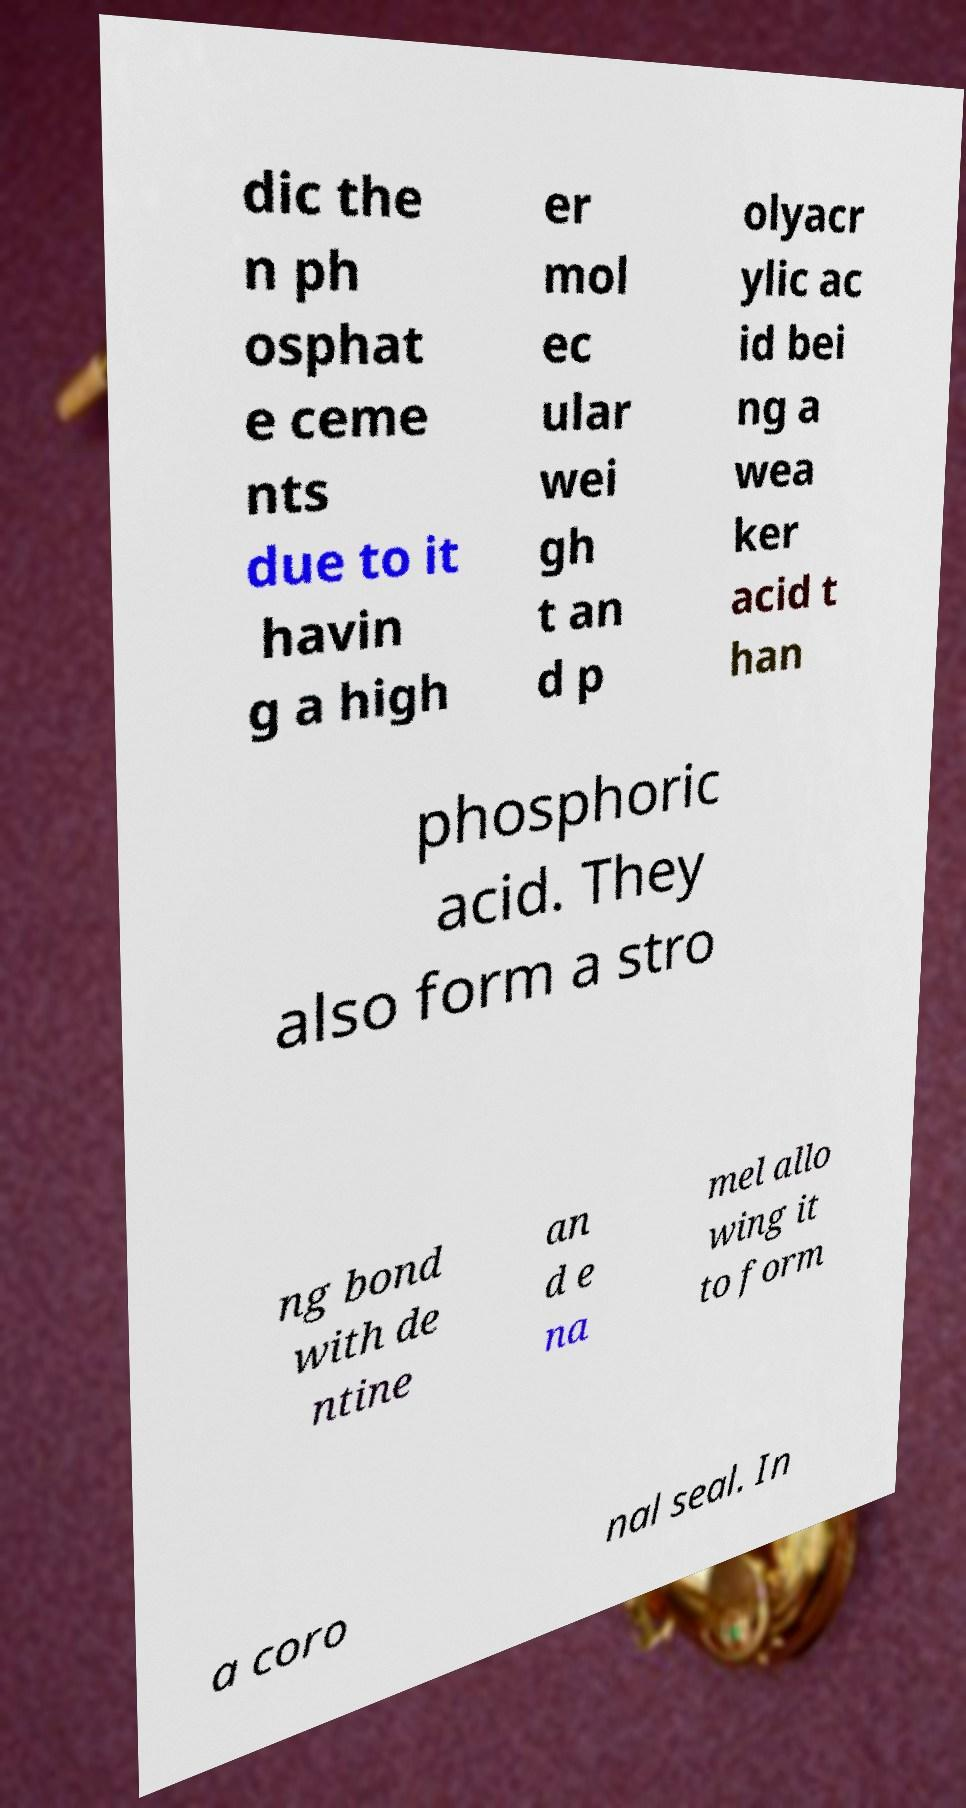I need the written content from this picture converted into text. Can you do that? dic the n ph osphat e ceme nts due to it havin g a high er mol ec ular wei gh t an d p olyacr ylic ac id bei ng a wea ker acid t han phosphoric acid. They also form a stro ng bond with de ntine an d e na mel allo wing it to form a coro nal seal. In 